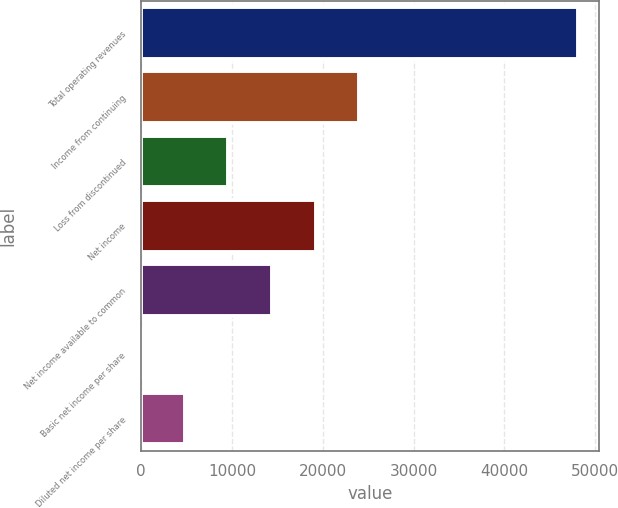Convert chart to OTSL. <chart><loc_0><loc_0><loc_500><loc_500><bar_chart><fcel>Total operating revenues<fcel>Income from continuing<fcel>Loss from discontinued<fcel>Net income<fcel>Net income available to common<fcel>Basic net income per share<fcel>Diluted net income per share<nl><fcel>48059<fcel>24029.5<fcel>9611.88<fcel>19223.7<fcel>14417.8<fcel>0.1<fcel>4805.99<nl></chart> 